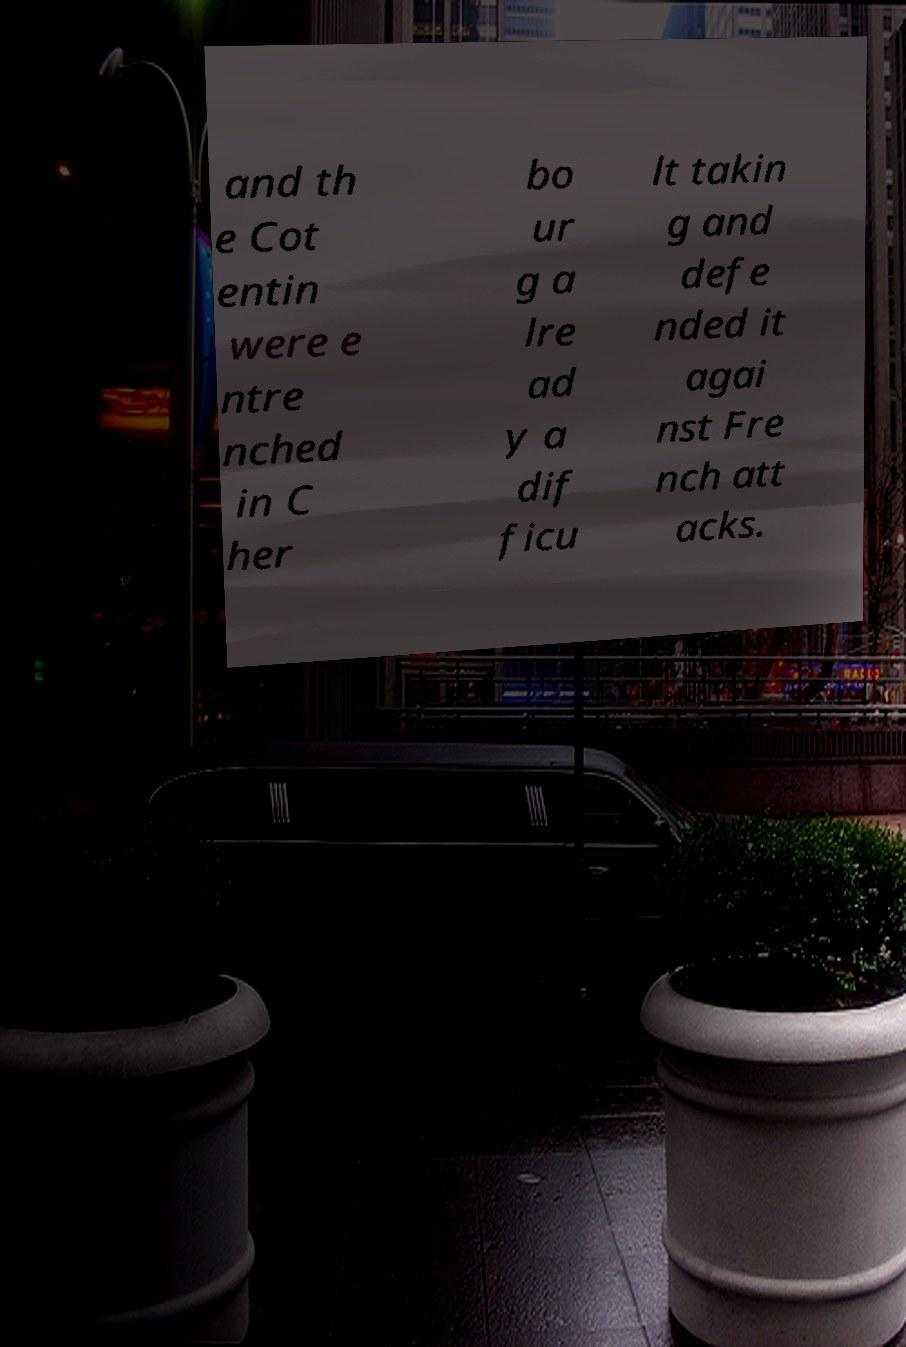There's text embedded in this image that I need extracted. Can you transcribe it verbatim? and th e Cot entin were e ntre nched in C her bo ur g a lre ad y a dif ficu lt takin g and defe nded it agai nst Fre nch att acks. 